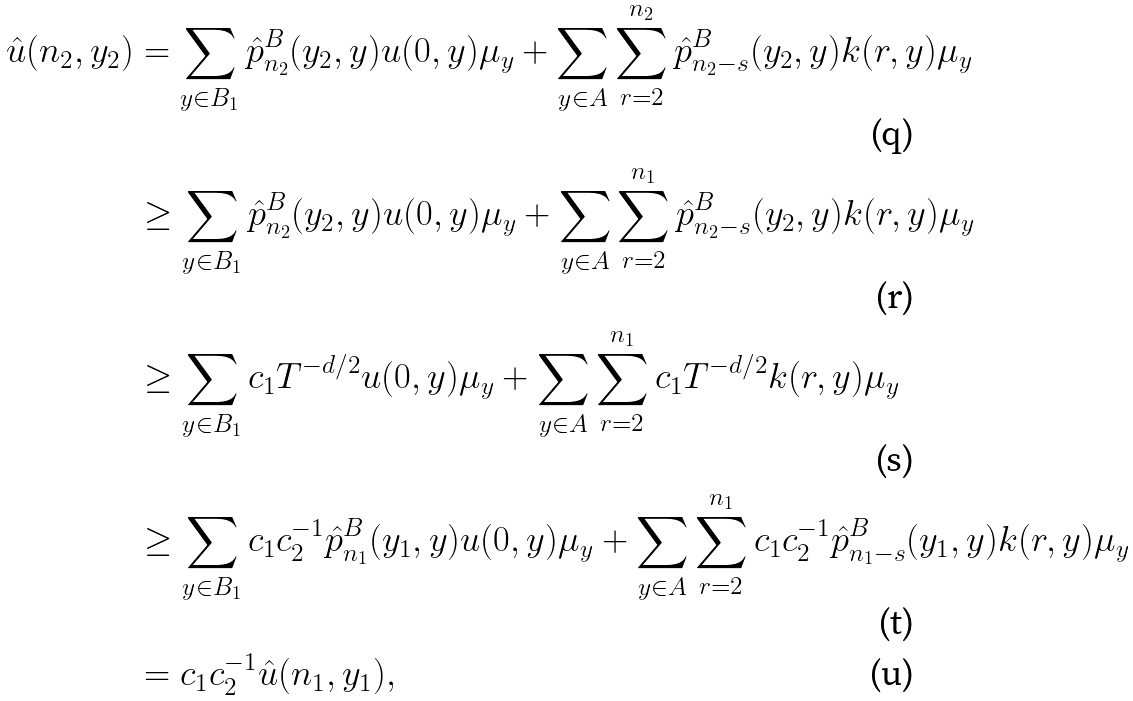Convert formula to latex. <formula><loc_0><loc_0><loc_500><loc_500>\hat { u } ( n _ { 2 } , y _ { 2 } ) & = \sum _ { y \in B _ { 1 } } \hat { p } ^ { B } _ { n _ { 2 } } ( y _ { 2 } , y ) u ( 0 , y ) \mu _ { y } + \sum _ { y \in A } \sum _ { r = 2 } ^ { n _ { 2 } } \hat { p } ^ { B } _ { n _ { 2 } - s } ( y _ { 2 } , y ) k ( r , y ) \mu _ { y } \\ & \geq \sum _ { y \in B _ { 1 } } \hat { p } ^ { B } _ { n _ { 2 } } ( y _ { 2 } , y ) u ( 0 , y ) \mu _ { y } + \sum _ { y \in A } \sum _ { r = 2 } ^ { n _ { 1 } } \hat { p } ^ { B } _ { n _ { 2 } - s } ( y _ { 2 } , y ) k ( r , y ) \mu _ { y } \\ & \geq \sum _ { y \in B _ { 1 } } c _ { 1 } T ^ { - d / 2 } u ( 0 , y ) \mu _ { y } + \sum _ { y \in A } \sum _ { r = 2 } ^ { n _ { 1 } } c _ { 1 } T ^ { - d / 2 } k ( r , y ) \mu _ { y } \\ & \geq \sum _ { y \in B _ { 1 } } c _ { 1 } c _ { 2 } ^ { - 1 } \hat { p } ^ { B } _ { n _ { 1 } } ( y _ { 1 } , y ) u ( 0 , y ) \mu _ { y } + \sum _ { y \in A } \sum _ { r = 2 } ^ { n _ { 1 } } c _ { 1 } c _ { 2 } ^ { - 1 } \hat { p } ^ { B } _ { n _ { 1 } - s } ( y _ { 1 } , y ) k ( r , y ) \mu _ { y } \\ & = c _ { 1 } c _ { 2 } ^ { - 1 } \hat { u } ( n _ { 1 } , y _ { 1 } ) ,</formula> 